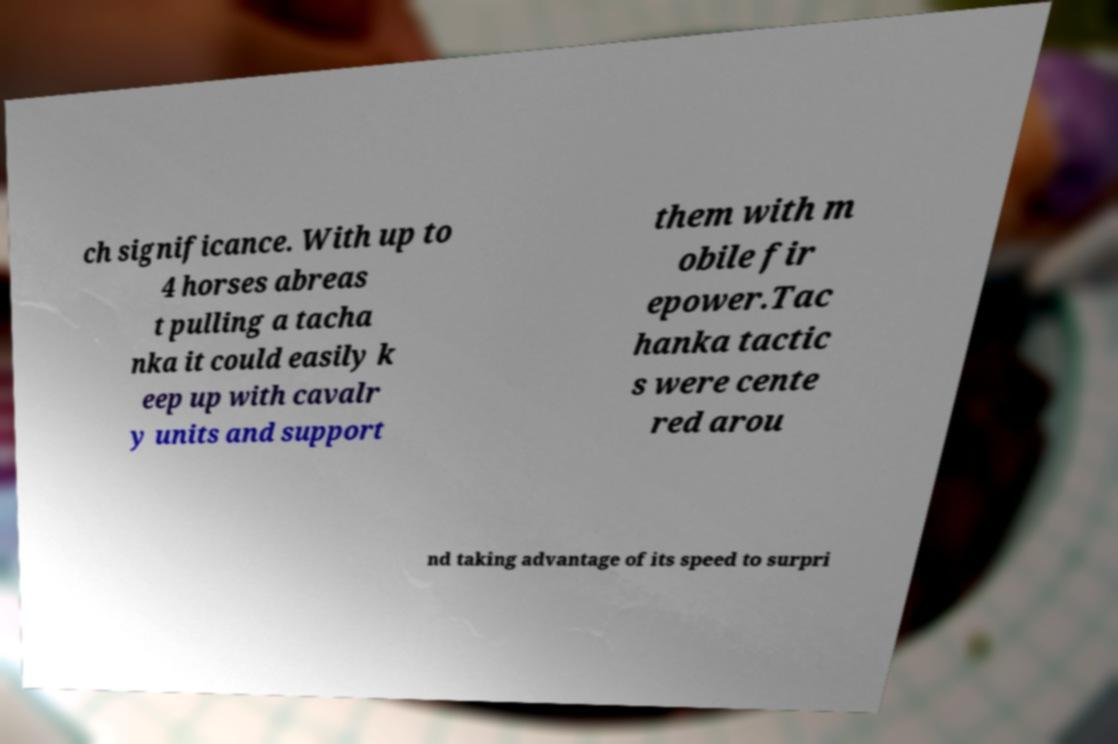Can you read and provide the text displayed in the image?This photo seems to have some interesting text. Can you extract and type it out for me? ch significance. With up to 4 horses abreas t pulling a tacha nka it could easily k eep up with cavalr y units and support them with m obile fir epower.Tac hanka tactic s were cente red arou nd taking advantage of its speed to surpri 